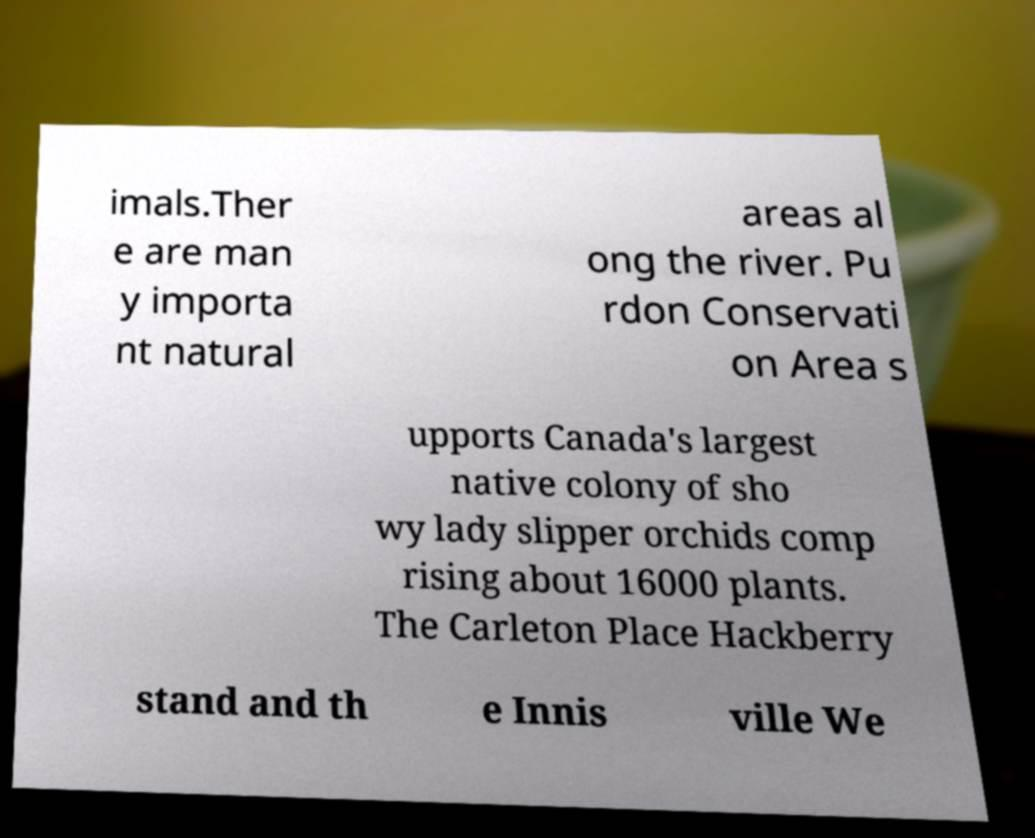Can you accurately transcribe the text from the provided image for me? imals.Ther e are man y importa nt natural areas al ong the river. Pu rdon Conservati on Area s upports Canada's largest native colony of sho wy lady slipper orchids comp rising about 16000 plants. The Carleton Place Hackberry stand and th e Innis ville We 